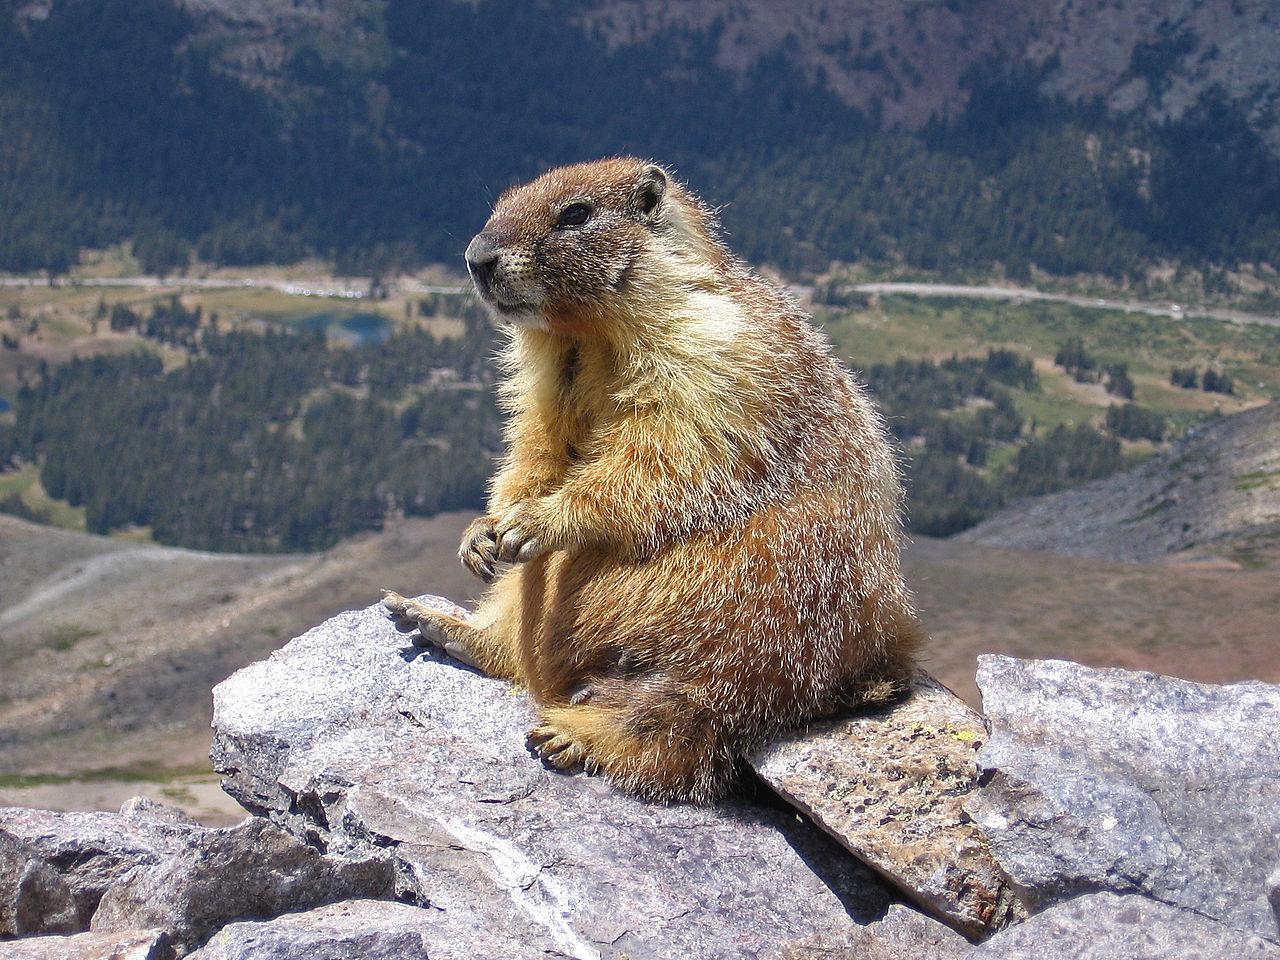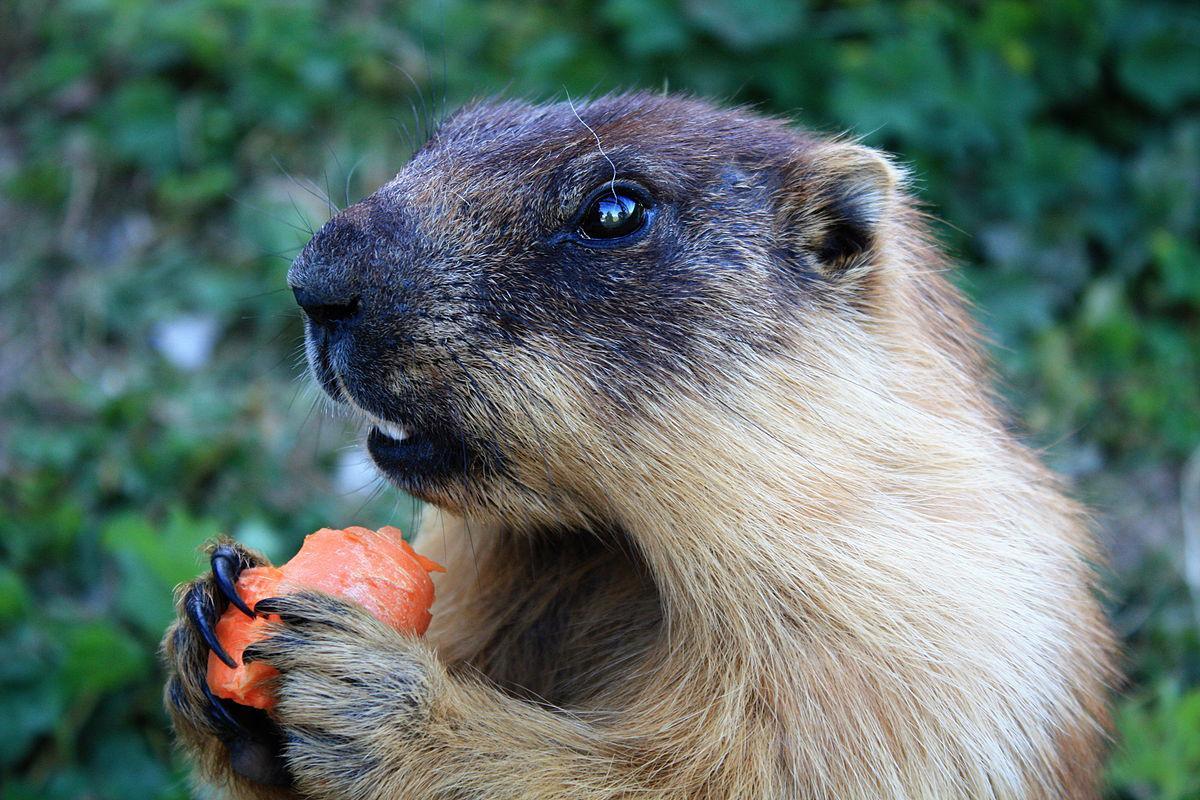The first image is the image on the left, the second image is the image on the right. Assess this claim about the two images: "There are no less than three animals". Correct or not? Answer yes or no. No. The first image is the image on the left, the second image is the image on the right. Examine the images to the left and right. Is the description "Each image contains exactly one prairie dog type animal." accurate? Answer yes or no. Yes. 